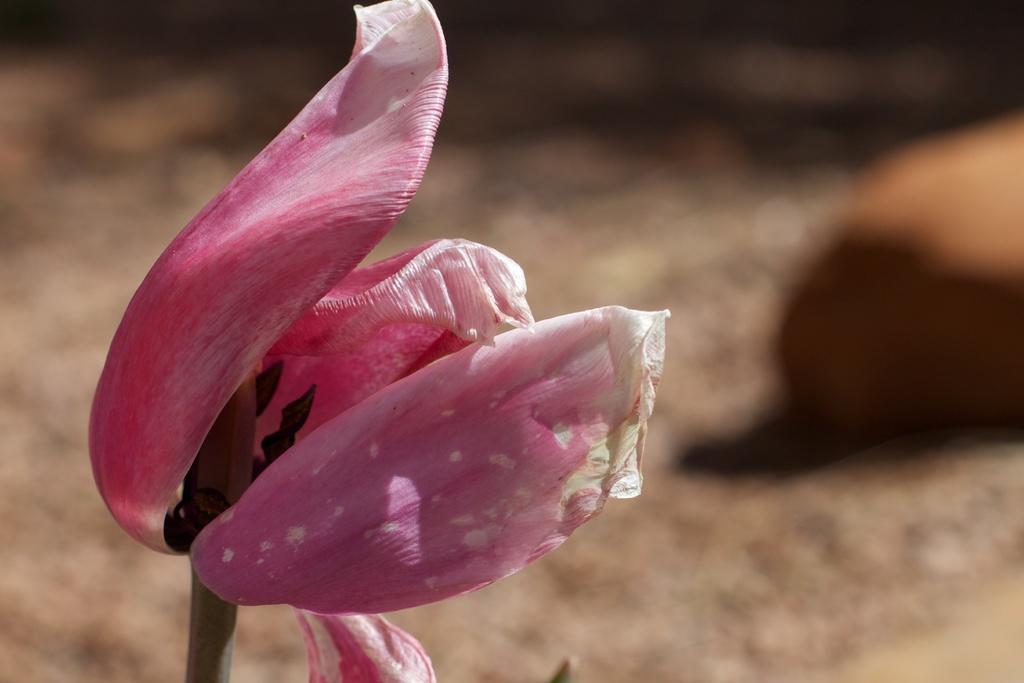How would you summarize this image in a sentence or two? In this picture I can see a pink color flower. The background of the image is blurred. 